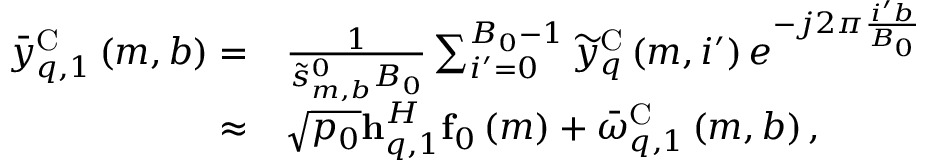Convert formula to latex. <formula><loc_0><loc_0><loc_500><loc_500>\begin{array} { r l } { { { \bar { y } } } _ { q , 1 } ^ { C } \left ( { m , b } \right ) = } & { \frac { 1 } { { \tilde { s } _ { m , b } ^ { 0 } { B _ { 0 } } } } \sum _ { i ^ { \prime } = 0 } ^ { { B _ { 0 } } - 1 } { { \widetilde { y } } _ { q } ^ { C } \left ( { m , i ^ { \prime } } \right ) { e ^ { - j 2 \pi \frac { { i ^ { \prime } b } } { { { B _ { 0 } } } } } } } } \\ { \approx } & { \sqrt { p _ { 0 } } { h } _ { q , 1 } ^ { H } { { f } _ { 0 } } \left ( m \right ) + { { \bar { \omega } } } _ { q , 1 } ^ { C } \left ( { m , b } \right ) , } \end{array}</formula> 